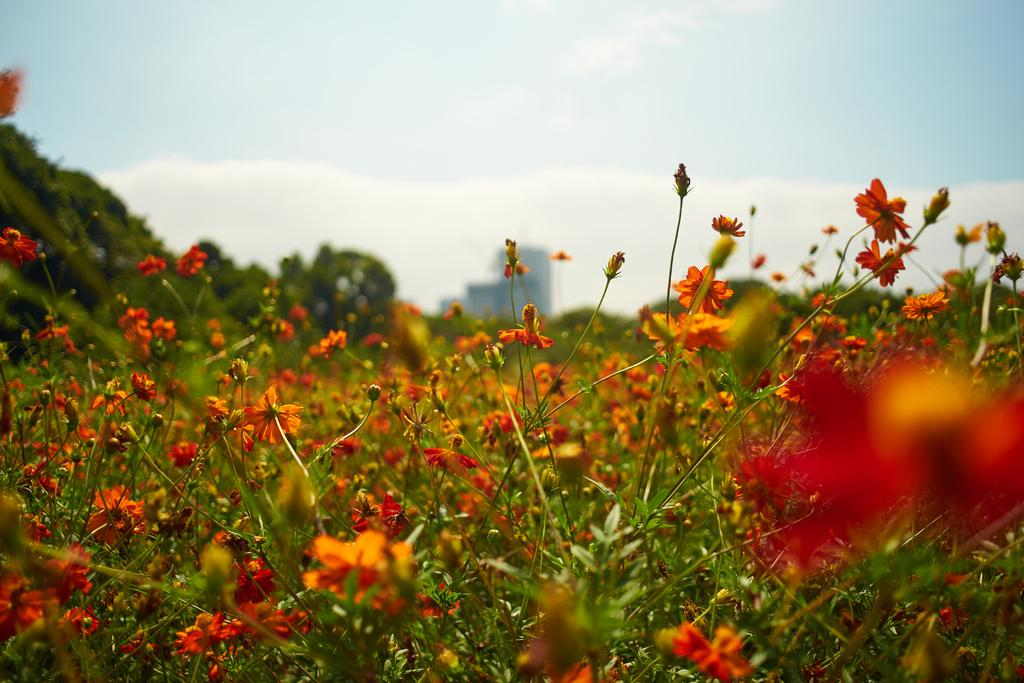What type of plants are at the bottom of the image? There are flower plants at the bottom of the image. What is visible at the top of the image? The sky is visible at the top of the image. Can you see a wren perched on one of the flower plants in the image? There is no wren present in the image. Is there a boot visible in the image? There is no boot present in the image. 